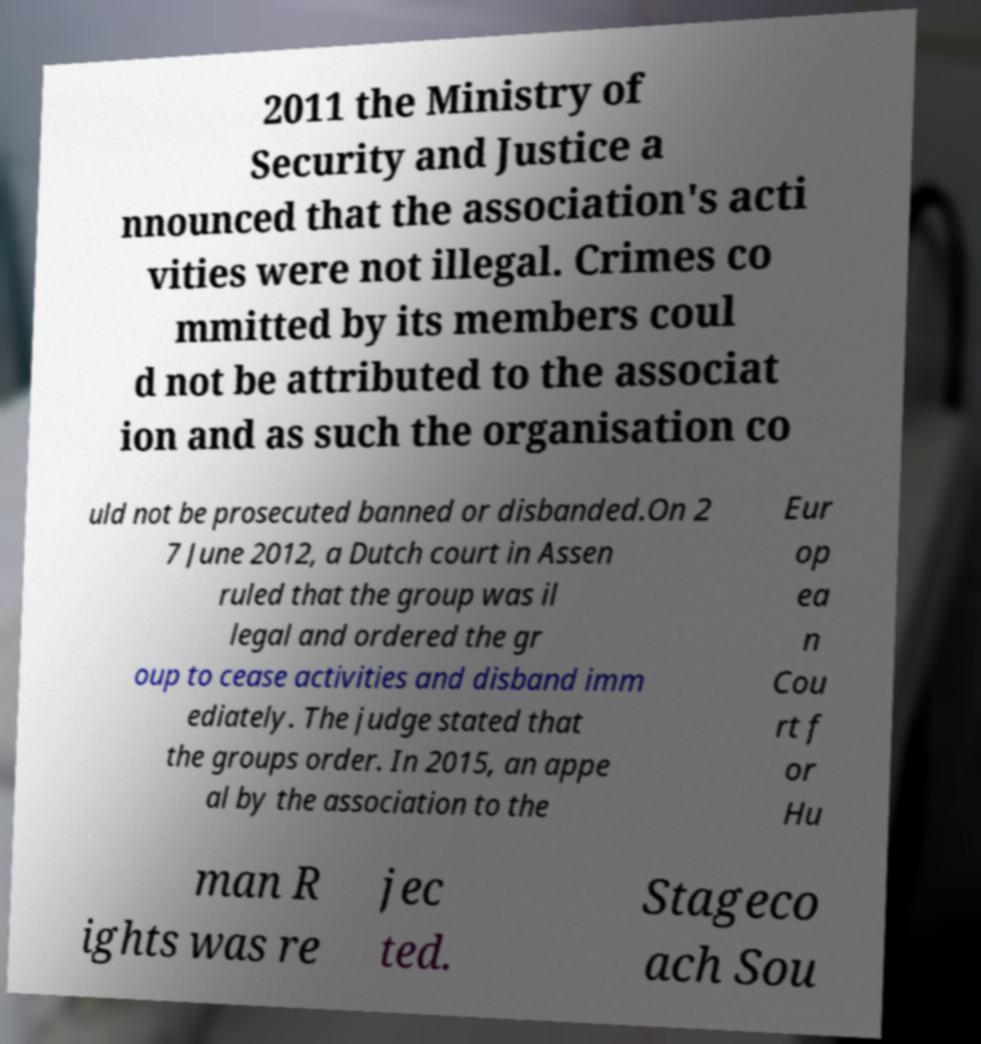There's text embedded in this image that I need extracted. Can you transcribe it verbatim? 2011 the Ministry of Security and Justice a nnounced that the association's acti vities were not illegal. Crimes co mmitted by its members coul d not be attributed to the associat ion and as such the organisation co uld not be prosecuted banned or disbanded.On 2 7 June 2012, a Dutch court in Assen ruled that the group was il legal and ordered the gr oup to cease activities and disband imm ediately. The judge stated that the groups order. In 2015, an appe al by the association to the Eur op ea n Cou rt f or Hu man R ights was re jec ted. Stageco ach Sou 